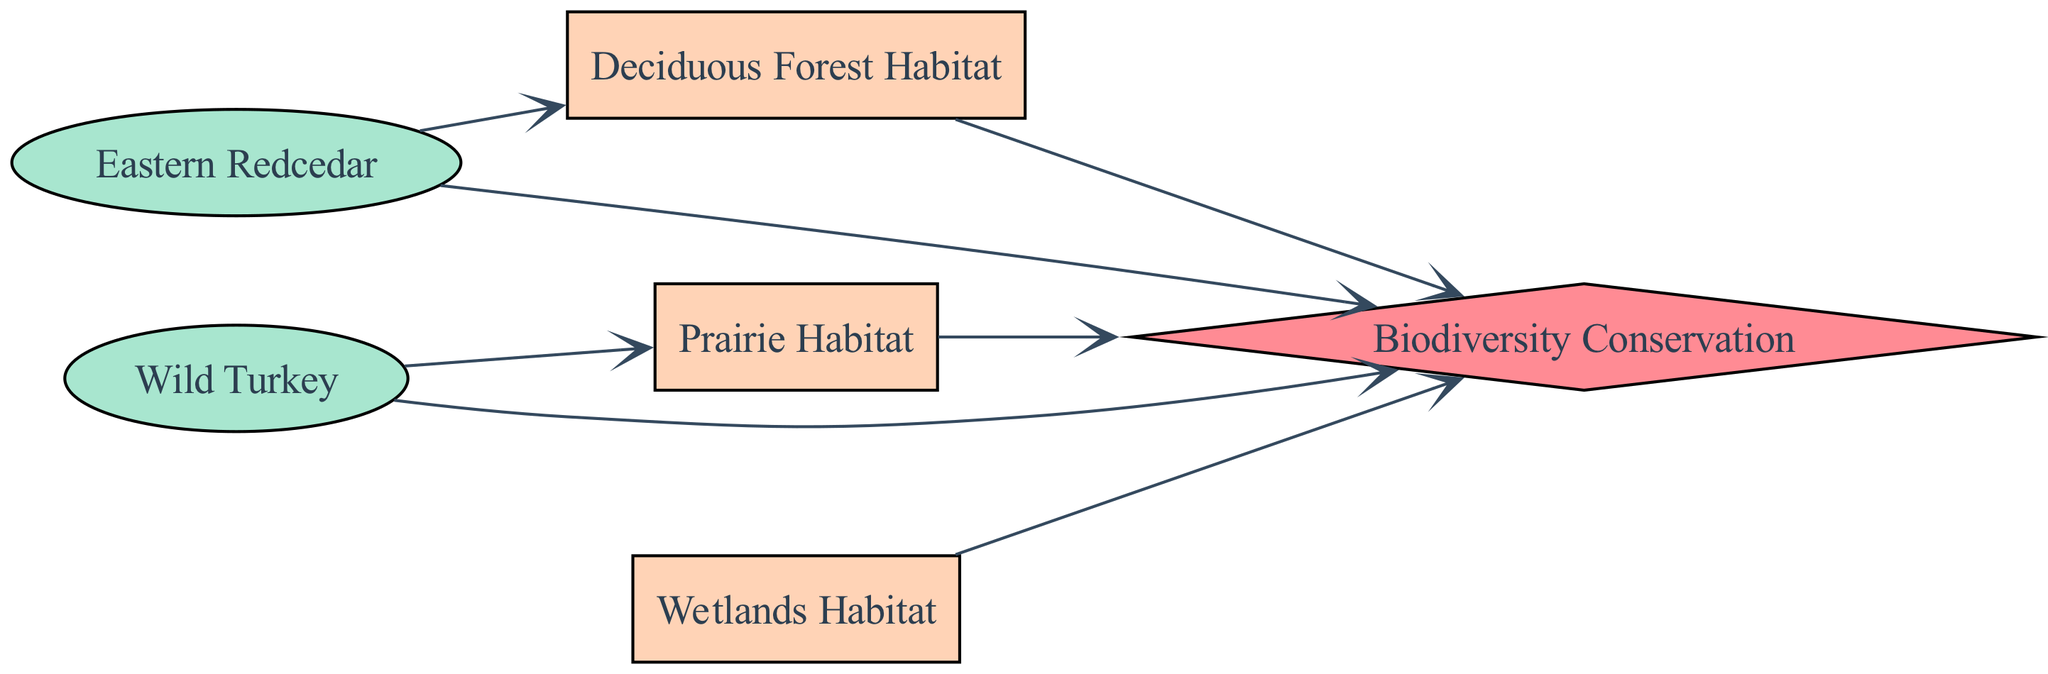What species is linked to the Deciduous Forest Habitat? The directed edge from "Eastern Redcedar" to "DeciduousForest" indicates a direct relationship between them. Thus, "Eastern Redcedar" is linked to the Deciduous Forest Habitat.
Answer: Eastern Redcedar How many habitats are represented in the diagram? By counting the nodes labeled as habitats, we see "Prairie Habitat," "Deciduous Forest Habitat," and "Wetlands Habitat," totaling three habitat nodes.
Answer: 3 Which species prefers the Prairie Habitat? The edge from "WildTurkey" to "Prairie" shows that "WildTurkey" is directly related and prefers this habitat.
Answer: Wild Turkey What is the common practice related to all habitats in the diagram? All edges from the habitat nodes lead to "Biodiversity," indicating that "Biodiversity Conservation" is a common practice across these habitats.
Answer: Biodiversity Conservation Which habitat has the most connections to species and practices? "Biodiversity" has edges connecting from all habitats and species, making it the most connected element. The individual habitats contribute but do not have as many direct connections as "Biodiversity."
Answer: Biodiversity Are there any species that relate to both habitats and the conservation practice? The "EasternRedcedar" connects to "DeciduousForest" and also to "Biodiversity," while "WildTurkey" connects to "Prairie" and "Biodiversity," meaning that both species relate to both habitats and the conservation practice.
Answer: Yes Which habitat is exclusively associated with a single species? The "Prairie Habitat" is connected only to "WildTurkey," whereas the other habitats are connected to multiple species or practices.
Answer: Prairie Habitat How many species are represented in the diagram? The nodes list two species: "Eastern Redcedar" and "Wild Turkey," so the count is two.
Answer: 2 What type of graph is this illustration? The diagram is a directed graph, shown by arrows indicating the direction of relationships from species to habitats and practices.
Answer: Directed Graph 